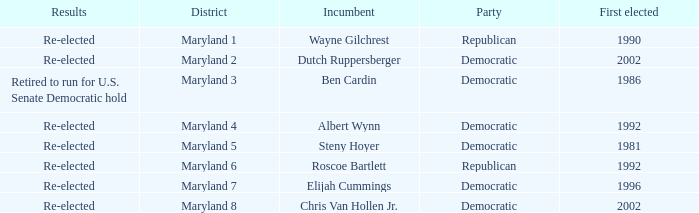Who is the incumbent who was first elected before 2002 from the maryland 3 district? Ben Cardin. 